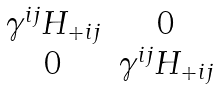<formula> <loc_0><loc_0><loc_500><loc_500>\begin{matrix} \gamma ^ { i j } H _ { + i j } & 0 \\ 0 & \gamma ^ { i j } H _ { + i j } \end{matrix}</formula> 